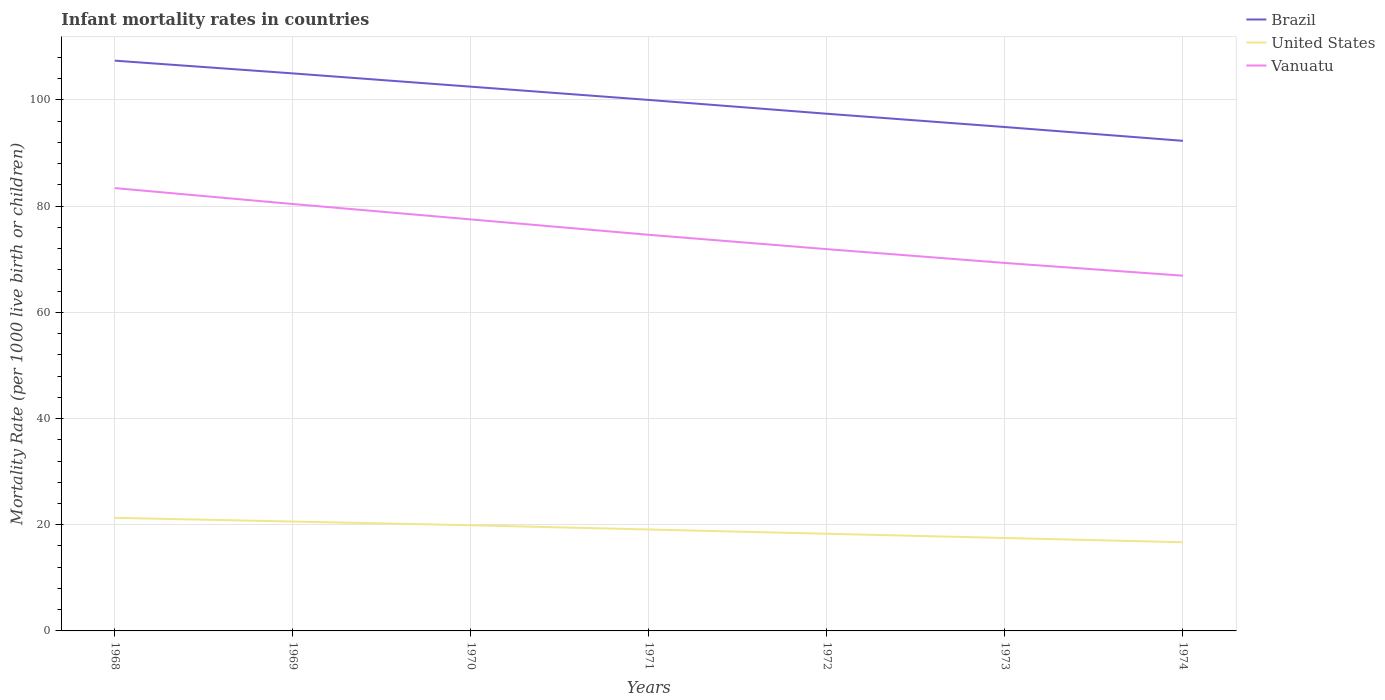Across all years, what is the maximum infant mortality rate in Brazil?
Your answer should be very brief. 92.3. In which year was the infant mortality rate in United States maximum?
Offer a very short reply. 1974. What is the difference between the highest and the second highest infant mortality rate in United States?
Offer a very short reply. 4.6. What is the difference between the highest and the lowest infant mortality rate in United States?
Your answer should be compact. 4. How many lines are there?
Give a very brief answer. 3. Where does the legend appear in the graph?
Make the answer very short. Top right. How many legend labels are there?
Ensure brevity in your answer.  3. What is the title of the graph?
Offer a terse response. Infant mortality rates in countries. What is the label or title of the X-axis?
Your answer should be very brief. Years. What is the label or title of the Y-axis?
Make the answer very short. Mortality Rate (per 1000 live birth or children). What is the Mortality Rate (per 1000 live birth or children) in Brazil in 1968?
Give a very brief answer. 107.4. What is the Mortality Rate (per 1000 live birth or children) in United States in 1968?
Give a very brief answer. 21.3. What is the Mortality Rate (per 1000 live birth or children) in Vanuatu in 1968?
Your response must be concise. 83.4. What is the Mortality Rate (per 1000 live birth or children) in Brazil in 1969?
Your response must be concise. 105. What is the Mortality Rate (per 1000 live birth or children) of United States in 1969?
Provide a short and direct response. 20.6. What is the Mortality Rate (per 1000 live birth or children) of Vanuatu in 1969?
Your answer should be compact. 80.4. What is the Mortality Rate (per 1000 live birth or children) of Brazil in 1970?
Your answer should be very brief. 102.5. What is the Mortality Rate (per 1000 live birth or children) of Vanuatu in 1970?
Your response must be concise. 77.5. What is the Mortality Rate (per 1000 live birth or children) in Vanuatu in 1971?
Your response must be concise. 74.6. What is the Mortality Rate (per 1000 live birth or children) in Brazil in 1972?
Your answer should be compact. 97.4. What is the Mortality Rate (per 1000 live birth or children) in United States in 1972?
Your answer should be compact. 18.3. What is the Mortality Rate (per 1000 live birth or children) of Vanuatu in 1972?
Offer a terse response. 71.9. What is the Mortality Rate (per 1000 live birth or children) of Brazil in 1973?
Keep it short and to the point. 94.9. What is the Mortality Rate (per 1000 live birth or children) in Vanuatu in 1973?
Make the answer very short. 69.3. What is the Mortality Rate (per 1000 live birth or children) of Brazil in 1974?
Your response must be concise. 92.3. What is the Mortality Rate (per 1000 live birth or children) in Vanuatu in 1974?
Provide a succinct answer. 66.9. Across all years, what is the maximum Mortality Rate (per 1000 live birth or children) in Brazil?
Provide a short and direct response. 107.4. Across all years, what is the maximum Mortality Rate (per 1000 live birth or children) of United States?
Make the answer very short. 21.3. Across all years, what is the maximum Mortality Rate (per 1000 live birth or children) in Vanuatu?
Offer a very short reply. 83.4. Across all years, what is the minimum Mortality Rate (per 1000 live birth or children) of Brazil?
Ensure brevity in your answer.  92.3. Across all years, what is the minimum Mortality Rate (per 1000 live birth or children) in Vanuatu?
Offer a terse response. 66.9. What is the total Mortality Rate (per 1000 live birth or children) of Brazil in the graph?
Keep it short and to the point. 699.5. What is the total Mortality Rate (per 1000 live birth or children) of United States in the graph?
Ensure brevity in your answer.  133.4. What is the total Mortality Rate (per 1000 live birth or children) of Vanuatu in the graph?
Offer a very short reply. 524. What is the difference between the Mortality Rate (per 1000 live birth or children) in Vanuatu in 1968 and that in 1969?
Provide a succinct answer. 3. What is the difference between the Mortality Rate (per 1000 live birth or children) in United States in 1968 and that in 1970?
Ensure brevity in your answer.  1.4. What is the difference between the Mortality Rate (per 1000 live birth or children) of United States in 1968 and that in 1971?
Your response must be concise. 2.2. What is the difference between the Mortality Rate (per 1000 live birth or children) in Vanuatu in 1968 and that in 1971?
Offer a very short reply. 8.8. What is the difference between the Mortality Rate (per 1000 live birth or children) in Brazil in 1968 and that in 1972?
Make the answer very short. 10. What is the difference between the Mortality Rate (per 1000 live birth or children) of Vanuatu in 1968 and that in 1972?
Keep it short and to the point. 11.5. What is the difference between the Mortality Rate (per 1000 live birth or children) in Brazil in 1968 and that in 1973?
Ensure brevity in your answer.  12.5. What is the difference between the Mortality Rate (per 1000 live birth or children) in United States in 1968 and that in 1973?
Give a very brief answer. 3.8. What is the difference between the Mortality Rate (per 1000 live birth or children) of Brazil in 1968 and that in 1974?
Keep it short and to the point. 15.1. What is the difference between the Mortality Rate (per 1000 live birth or children) in United States in 1968 and that in 1974?
Provide a succinct answer. 4.6. What is the difference between the Mortality Rate (per 1000 live birth or children) of Vanuatu in 1968 and that in 1974?
Give a very brief answer. 16.5. What is the difference between the Mortality Rate (per 1000 live birth or children) of Brazil in 1969 and that in 1970?
Provide a short and direct response. 2.5. What is the difference between the Mortality Rate (per 1000 live birth or children) of United States in 1969 and that in 1970?
Your answer should be compact. 0.7. What is the difference between the Mortality Rate (per 1000 live birth or children) in Brazil in 1969 and that in 1971?
Provide a succinct answer. 5. What is the difference between the Mortality Rate (per 1000 live birth or children) in Brazil in 1969 and that in 1972?
Provide a short and direct response. 7.6. What is the difference between the Mortality Rate (per 1000 live birth or children) of Vanuatu in 1969 and that in 1972?
Offer a very short reply. 8.5. What is the difference between the Mortality Rate (per 1000 live birth or children) in United States in 1969 and that in 1973?
Keep it short and to the point. 3.1. What is the difference between the Mortality Rate (per 1000 live birth or children) in Brazil in 1970 and that in 1971?
Offer a very short reply. 2.5. What is the difference between the Mortality Rate (per 1000 live birth or children) in United States in 1970 and that in 1971?
Offer a terse response. 0.8. What is the difference between the Mortality Rate (per 1000 live birth or children) in United States in 1970 and that in 1973?
Your answer should be compact. 2.4. What is the difference between the Mortality Rate (per 1000 live birth or children) of United States in 1970 and that in 1974?
Provide a succinct answer. 3.2. What is the difference between the Mortality Rate (per 1000 live birth or children) of Brazil in 1971 and that in 1972?
Make the answer very short. 2.6. What is the difference between the Mortality Rate (per 1000 live birth or children) of Vanuatu in 1971 and that in 1972?
Ensure brevity in your answer.  2.7. What is the difference between the Mortality Rate (per 1000 live birth or children) in Brazil in 1971 and that in 1974?
Make the answer very short. 7.7. What is the difference between the Mortality Rate (per 1000 live birth or children) in Vanuatu in 1971 and that in 1974?
Keep it short and to the point. 7.7. What is the difference between the Mortality Rate (per 1000 live birth or children) in Brazil in 1972 and that in 1973?
Provide a succinct answer. 2.5. What is the difference between the Mortality Rate (per 1000 live birth or children) of United States in 1972 and that in 1974?
Provide a short and direct response. 1.6. What is the difference between the Mortality Rate (per 1000 live birth or children) of Vanuatu in 1972 and that in 1974?
Offer a terse response. 5. What is the difference between the Mortality Rate (per 1000 live birth or children) in Brazil in 1968 and the Mortality Rate (per 1000 live birth or children) in United States in 1969?
Provide a short and direct response. 86.8. What is the difference between the Mortality Rate (per 1000 live birth or children) of United States in 1968 and the Mortality Rate (per 1000 live birth or children) of Vanuatu in 1969?
Provide a succinct answer. -59.1. What is the difference between the Mortality Rate (per 1000 live birth or children) of Brazil in 1968 and the Mortality Rate (per 1000 live birth or children) of United States in 1970?
Keep it short and to the point. 87.5. What is the difference between the Mortality Rate (per 1000 live birth or children) in Brazil in 1968 and the Mortality Rate (per 1000 live birth or children) in Vanuatu in 1970?
Offer a very short reply. 29.9. What is the difference between the Mortality Rate (per 1000 live birth or children) in United States in 1968 and the Mortality Rate (per 1000 live birth or children) in Vanuatu in 1970?
Give a very brief answer. -56.2. What is the difference between the Mortality Rate (per 1000 live birth or children) in Brazil in 1968 and the Mortality Rate (per 1000 live birth or children) in United States in 1971?
Provide a succinct answer. 88.3. What is the difference between the Mortality Rate (per 1000 live birth or children) in Brazil in 1968 and the Mortality Rate (per 1000 live birth or children) in Vanuatu in 1971?
Your answer should be very brief. 32.8. What is the difference between the Mortality Rate (per 1000 live birth or children) of United States in 1968 and the Mortality Rate (per 1000 live birth or children) of Vanuatu in 1971?
Your answer should be compact. -53.3. What is the difference between the Mortality Rate (per 1000 live birth or children) in Brazil in 1968 and the Mortality Rate (per 1000 live birth or children) in United States in 1972?
Provide a short and direct response. 89.1. What is the difference between the Mortality Rate (per 1000 live birth or children) of Brazil in 1968 and the Mortality Rate (per 1000 live birth or children) of Vanuatu in 1972?
Give a very brief answer. 35.5. What is the difference between the Mortality Rate (per 1000 live birth or children) of United States in 1968 and the Mortality Rate (per 1000 live birth or children) of Vanuatu in 1972?
Keep it short and to the point. -50.6. What is the difference between the Mortality Rate (per 1000 live birth or children) of Brazil in 1968 and the Mortality Rate (per 1000 live birth or children) of United States in 1973?
Your answer should be compact. 89.9. What is the difference between the Mortality Rate (per 1000 live birth or children) in Brazil in 1968 and the Mortality Rate (per 1000 live birth or children) in Vanuatu in 1973?
Keep it short and to the point. 38.1. What is the difference between the Mortality Rate (per 1000 live birth or children) in United States in 1968 and the Mortality Rate (per 1000 live birth or children) in Vanuatu in 1973?
Offer a terse response. -48. What is the difference between the Mortality Rate (per 1000 live birth or children) of Brazil in 1968 and the Mortality Rate (per 1000 live birth or children) of United States in 1974?
Provide a short and direct response. 90.7. What is the difference between the Mortality Rate (per 1000 live birth or children) of Brazil in 1968 and the Mortality Rate (per 1000 live birth or children) of Vanuatu in 1974?
Your answer should be very brief. 40.5. What is the difference between the Mortality Rate (per 1000 live birth or children) in United States in 1968 and the Mortality Rate (per 1000 live birth or children) in Vanuatu in 1974?
Offer a very short reply. -45.6. What is the difference between the Mortality Rate (per 1000 live birth or children) of Brazil in 1969 and the Mortality Rate (per 1000 live birth or children) of United States in 1970?
Keep it short and to the point. 85.1. What is the difference between the Mortality Rate (per 1000 live birth or children) of Brazil in 1969 and the Mortality Rate (per 1000 live birth or children) of Vanuatu in 1970?
Ensure brevity in your answer.  27.5. What is the difference between the Mortality Rate (per 1000 live birth or children) in United States in 1969 and the Mortality Rate (per 1000 live birth or children) in Vanuatu in 1970?
Provide a succinct answer. -56.9. What is the difference between the Mortality Rate (per 1000 live birth or children) of Brazil in 1969 and the Mortality Rate (per 1000 live birth or children) of United States in 1971?
Offer a terse response. 85.9. What is the difference between the Mortality Rate (per 1000 live birth or children) in Brazil in 1969 and the Mortality Rate (per 1000 live birth or children) in Vanuatu in 1971?
Your answer should be very brief. 30.4. What is the difference between the Mortality Rate (per 1000 live birth or children) of United States in 1969 and the Mortality Rate (per 1000 live birth or children) of Vanuatu in 1971?
Your answer should be very brief. -54. What is the difference between the Mortality Rate (per 1000 live birth or children) of Brazil in 1969 and the Mortality Rate (per 1000 live birth or children) of United States in 1972?
Ensure brevity in your answer.  86.7. What is the difference between the Mortality Rate (per 1000 live birth or children) of Brazil in 1969 and the Mortality Rate (per 1000 live birth or children) of Vanuatu in 1972?
Give a very brief answer. 33.1. What is the difference between the Mortality Rate (per 1000 live birth or children) in United States in 1969 and the Mortality Rate (per 1000 live birth or children) in Vanuatu in 1972?
Ensure brevity in your answer.  -51.3. What is the difference between the Mortality Rate (per 1000 live birth or children) in Brazil in 1969 and the Mortality Rate (per 1000 live birth or children) in United States in 1973?
Offer a very short reply. 87.5. What is the difference between the Mortality Rate (per 1000 live birth or children) of Brazil in 1969 and the Mortality Rate (per 1000 live birth or children) of Vanuatu in 1973?
Give a very brief answer. 35.7. What is the difference between the Mortality Rate (per 1000 live birth or children) of United States in 1969 and the Mortality Rate (per 1000 live birth or children) of Vanuatu in 1973?
Provide a succinct answer. -48.7. What is the difference between the Mortality Rate (per 1000 live birth or children) in Brazil in 1969 and the Mortality Rate (per 1000 live birth or children) in United States in 1974?
Ensure brevity in your answer.  88.3. What is the difference between the Mortality Rate (per 1000 live birth or children) of Brazil in 1969 and the Mortality Rate (per 1000 live birth or children) of Vanuatu in 1974?
Make the answer very short. 38.1. What is the difference between the Mortality Rate (per 1000 live birth or children) of United States in 1969 and the Mortality Rate (per 1000 live birth or children) of Vanuatu in 1974?
Offer a very short reply. -46.3. What is the difference between the Mortality Rate (per 1000 live birth or children) of Brazil in 1970 and the Mortality Rate (per 1000 live birth or children) of United States in 1971?
Your answer should be very brief. 83.4. What is the difference between the Mortality Rate (per 1000 live birth or children) of Brazil in 1970 and the Mortality Rate (per 1000 live birth or children) of Vanuatu in 1971?
Your response must be concise. 27.9. What is the difference between the Mortality Rate (per 1000 live birth or children) of United States in 1970 and the Mortality Rate (per 1000 live birth or children) of Vanuatu in 1971?
Your answer should be very brief. -54.7. What is the difference between the Mortality Rate (per 1000 live birth or children) of Brazil in 1970 and the Mortality Rate (per 1000 live birth or children) of United States in 1972?
Make the answer very short. 84.2. What is the difference between the Mortality Rate (per 1000 live birth or children) in Brazil in 1970 and the Mortality Rate (per 1000 live birth or children) in Vanuatu in 1972?
Ensure brevity in your answer.  30.6. What is the difference between the Mortality Rate (per 1000 live birth or children) of United States in 1970 and the Mortality Rate (per 1000 live birth or children) of Vanuatu in 1972?
Your answer should be very brief. -52. What is the difference between the Mortality Rate (per 1000 live birth or children) in Brazil in 1970 and the Mortality Rate (per 1000 live birth or children) in United States in 1973?
Offer a very short reply. 85. What is the difference between the Mortality Rate (per 1000 live birth or children) of Brazil in 1970 and the Mortality Rate (per 1000 live birth or children) of Vanuatu in 1973?
Provide a short and direct response. 33.2. What is the difference between the Mortality Rate (per 1000 live birth or children) of United States in 1970 and the Mortality Rate (per 1000 live birth or children) of Vanuatu in 1973?
Offer a terse response. -49.4. What is the difference between the Mortality Rate (per 1000 live birth or children) of Brazil in 1970 and the Mortality Rate (per 1000 live birth or children) of United States in 1974?
Provide a short and direct response. 85.8. What is the difference between the Mortality Rate (per 1000 live birth or children) in Brazil in 1970 and the Mortality Rate (per 1000 live birth or children) in Vanuatu in 1974?
Offer a very short reply. 35.6. What is the difference between the Mortality Rate (per 1000 live birth or children) in United States in 1970 and the Mortality Rate (per 1000 live birth or children) in Vanuatu in 1974?
Give a very brief answer. -47. What is the difference between the Mortality Rate (per 1000 live birth or children) of Brazil in 1971 and the Mortality Rate (per 1000 live birth or children) of United States in 1972?
Provide a short and direct response. 81.7. What is the difference between the Mortality Rate (per 1000 live birth or children) in Brazil in 1971 and the Mortality Rate (per 1000 live birth or children) in Vanuatu in 1972?
Keep it short and to the point. 28.1. What is the difference between the Mortality Rate (per 1000 live birth or children) of United States in 1971 and the Mortality Rate (per 1000 live birth or children) of Vanuatu in 1972?
Offer a very short reply. -52.8. What is the difference between the Mortality Rate (per 1000 live birth or children) in Brazil in 1971 and the Mortality Rate (per 1000 live birth or children) in United States in 1973?
Your answer should be very brief. 82.5. What is the difference between the Mortality Rate (per 1000 live birth or children) in Brazil in 1971 and the Mortality Rate (per 1000 live birth or children) in Vanuatu in 1973?
Ensure brevity in your answer.  30.7. What is the difference between the Mortality Rate (per 1000 live birth or children) of United States in 1971 and the Mortality Rate (per 1000 live birth or children) of Vanuatu in 1973?
Your answer should be very brief. -50.2. What is the difference between the Mortality Rate (per 1000 live birth or children) in Brazil in 1971 and the Mortality Rate (per 1000 live birth or children) in United States in 1974?
Provide a short and direct response. 83.3. What is the difference between the Mortality Rate (per 1000 live birth or children) in Brazil in 1971 and the Mortality Rate (per 1000 live birth or children) in Vanuatu in 1974?
Make the answer very short. 33.1. What is the difference between the Mortality Rate (per 1000 live birth or children) of United States in 1971 and the Mortality Rate (per 1000 live birth or children) of Vanuatu in 1974?
Provide a short and direct response. -47.8. What is the difference between the Mortality Rate (per 1000 live birth or children) in Brazil in 1972 and the Mortality Rate (per 1000 live birth or children) in United States in 1973?
Provide a succinct answer. 79.9. What is the difference between the Mortality Rate (per 1000 live birth or children) in Brazil in 1972 and the Mortality Rate (per 1000 live birth or children) in Vanuatu in 1973?
Ensure brevity in your answer.  28.1. What is the difference between the Mortality Rate (per 1000 live birth or children) in United States in 1972 and the Mortality Rate (per 1000 live birth or children) in Vanuatu in 1973?
Provide a succinct answer. -51. What is the difference between the Mortality Rate (per 1000 live birth or children) of Brazil in 1972 and the Mortality Rate (per 1000 live birth or children) of United States in 1974?
Your response must be concise. 80.7. What is the difference between the Mortality Rate (per 1000 live birth or children) of Brazil in 1972 and the Mortality Rate (per 1000 live birth or children) of Vanuatu in 1974?
Offer a terse response. 30.5. What is the difference between the Mortality Rate (per 1000 live birth or children) in United States in 1972 and the Mortality Rate (per 1000 live birth or children) in Vanuatu in 1974?
Ensure brevity in your answer.  -48.6. What is the difference between the Mortality Rate (per 1000 live birth or children) of Brazil in 1973 and the Mortality Rate (per 1000 live birth or children) of United States in 1974?
Provide a succinct answer. 78.2. What is the difference between the Mortality Rate (per 1000 live birth or children) in United States in 1973 and the Mortality Rate (per 1000 live birth or children) in Vanuatu in 1974?
Provide a short and direct response. -49.4. What is the average Mortality Rate (per 1000 live birth or children) in Brazil per year?
Your answer should be compact. 99.93. What is the average Mortality Rate (per 1000 live birth or children) in United States per year?
Offer a terse response. 19.06. What is the average Mortality Rate (per 1000 live birth or children) of Vanuatu per year?
Offer a terse response. 74.86. In the year 1968, what is the difference between the Mortality Rate (per 1000 live birth or children) of Brazil and Mortality Rate (per 1000 live birth or children) of United States?
Keep it short and to the point. 86.1. In the year 1968, what is the difference between the Mortality Rate (per 1000 live birth or children) of United States and Mortality Rate (per 1000 live birth or children) of Vanuatu?
Give a very brief answer. -62.1. In the year 1969, what is the difference between the Mortality Rate (per 1000 live birth or children) of Brazil and Mortality Rate (per 1000 live birth or children) of United States?
Your answer should be very brief. 84.4. In the year 1969, what is the difference between the Mortality Rate (per 1000 live birth or children) of Brazil and Mortality Rate (per 1000 live birth or children) of Vanuatu?
Make the answer very short. 24.6. In the year 1969, what is the difference between the Mortality Rate (per 1000 live birth or children) in United States and Mortality Rate (per 1000 live birth or children) in Vanuatu?
Make the answer very short. -59.8. In the year 1970, what is the difference between the Mortality Rate (per 1000 live birth or children) in Brazil and Mortality Rate (per 1000 live birth or children) in United States?
Offer a very short reply. 82.6. In the year 1970, what is the difference between the Mortality Rate (per 1000 live birth or children) of United States and Mortality Rate (per 1000 live birth or children) of Vanuatu?
Give a very brief answer. -57.6. In the year 1971, what is the difference between the Mortality Rate (per 1000 live birth or children) of Brazil and Mortality Rate (per 1000 live birth or children) of United States?
Offer a terse response. 80.9. In the year 1971, what is the difference between the Mortality Rate (per 1000 live birth or children) in Brazil and Mortality Rate (per 1000 live birth or children) in Vanuatu?
Provide a succinct answer. 25.4. In the year 1971, what is the difference between the Mortality Rate (per 1000 live birth or children) of United States and Mortality Rate (per 1000 live birth or children) of Vanuatu?
Make the answer very short. -55.5. In the year 1972, what is the difference between the Mortality Rate (per 1000 live birth or children) in Brazil and Mortality Rate (per 1000 live birth or children) in United States?
Ensure brevity in your answer.  79.1. In the year 1972, what is the difference between the Mortality Rate (per 1000 live birth or children) in United States and Mortality Rate (per 1000 live birth or children) in Vanuatu?
Your answer should be very brief. -53.6. In the year 1973, what is the difference between the Mortality Rate (per 1000 live birth or children) in Brazil and Mortality Rate (per 1000 live birth or children) in United States?
Your answer should be very brief. 77.4. In the year 1973, what is the difference between the Mortality Rate (per 1000 live birth or children) of Brazil and Mortality Rate (per 1000 live birth or children) of Vanuatu?
Provide a short and direct response. 25.6. In the year 1973, what is the difference between the Mortality Rate (per 1000 live birth or children) in United States and Mortality Rate (per 1000 live birth or children) in Vanuatu?
Offer a very short reply. -51.8. In the year 1974, what is the difference between the Mortality Rate (per 1000 live birth or children) of Brazil and Mortality Rate (per 1000 live birth or children) of United States?
Provide a succinct answer. 75.6. In the year 1974, what is the difference between the Mortality Rate (per 1000 live birth or children) of Brazil and Mortality Rate (per 1000 live birth or children) of Vanuatu?
Your answer should be very brief. 25.4. In the year 1974, what is the difference between the Mortality Rate (per 1000 live birth or children) of United States and Mortality Rate (per 1000 live birth or children) of Vanuatu?
Offer a very short reply. -50.2. What is the ratio of the Mortality Rate (per 1000 live birth or children) of Brazil in 1968 to that in 1969?
Provide a short and direct response. 1.02. What is the ratio of the Mortality Rate (per 1000 live birth or children) of United States in 1968 to that in 1969?
Your answer should be compact. 1.03. What is the ratio of the Mortality Rate (per 1000 live birth or children) of Vanuatu in 1968 to that in 1969?
Your response must be concise. 1.04. What is the ratio of the Mortality Rate (per 1000 live birth or children) in Brazil in 1968 to that in 1970?
Keep it short and to the point. 1.05. What is the ratio of the Mortality Rate (per 1000 live birth or children) of United States in 1968 to that in 1970?
Offer a terse response. 1.07. What is the ratio of the Mortality Rate (per 1000 live birth or children) in Vanuatu in 1968 to that in 1970?
Keep it short and to the point. 1.08. What is the ratio of the Mortality Rate (per 1000 live birth or children) of Brazil in 1968 to that in 1971?
Provide a short and direct response. 1.07. What is the ratio of the Mortality Rate (per 1000 live birth or children) of United States in 1968 to that in 1971?
Offer a terse response. 1.12. What is the ratio of the Mortality Rate (per 1000 live birth or children) of Vanuatu in 1968 to that in 1971?
Your answer should be very brief. 1.12. What is the ratio of the Mortality Rate (per 1000 live birth or children) of Brazil in 1968 to that in 1972?
Give a very brief answer. 1.1. What is the ratio of the Mortality Rate (per 1000 live birth or children) in United States in 1968 to that in 1972?
Give a very brief answer. 1.16. What is the ratio of the Mortality Rate (per 1000 live birth or children) of Vanuatu in 1968 to that in 1972?
Give a very brief answer. 1.16. What is the ratio of the Mortality Rate (per 1000 live birth or children) of Brazil in 1968 to that in 1973?
Your answer should be compact. 1.13. What is the ratio of the Mortality Rate (per 1000 live birth or children) of United States in 1968 to that in 1973?
Give a very brief answer. 1.22. What is the ratio of the Mortality Rate (per 1000 live birth or children) of Vanuatu in 1968 to that in 1973?
Your response must be concise. 1.2. What is the ratio of the Mortality Rate (per 1000 live birth or children) in Brazil in 1968 to that in 1974?
Keep it short and to the point. 1.16. What is the ratio of the Mortality Rate (per 1000 live birth or children) in United States in 1968 to that in 1974?
Offer a very short reply. 1.28. What is the ratio of the Mortality Rate (per 1000 live birth or children) in Vanuatu in 1968 to that in 1974?
Give a very brief answer. 1.25. What is the ratio of the Mortality Rate (per 1000 live birth or children) of Brazil in 1969 to that in 1970?
Your answer should be compact. 1.02. What is the ratio of the Mortality Rate (per 1000 live birth or children) of United States in 1969 to that in 1970?
Provide a succinct answer. 1.04. What is the ratio of the Mortality Rate (per 1000 live birth or children) of Vanuatu in 1969 to that in 1970?
Make the answer very short. 1.04. What is the ratio of the Mortality Rate (per 1000 live birth or children) of Brazil in 1969 to that in 1971?
Your response must be concise. 1.05. What is the ratio of the Mortality Rate (per 1000 live birth or children) in United States in 1969 to that in 1971?
Provide a short and direct response. 1.08. What is the ratio of the Mortality Rate (per 1000 live birth or children) in Vanuatu in 1969 to that in 1971?
Provide a succinct answer. 1.08. What is the ratio of the Mortality Rate (per 1000 live birth or children) of Brazil in 1969 to that in 1972?
Offer a very short reply. 1.08. What is the ratio of the Mortality Rate (per 1000 live birth or children) in United States in 1969 to that in 1972?
Ensure brevity in your answer.  1.13. What is the ratio of the Mortality Rate (per 1000 live birth or children) of Vanuatu in 1969 to that in 1972?
Provide a succinct answer. 1.12. What is the ratio of the Mortality Rate (per 1000 live birth or children) of Brazil in 1969 to that in 1973?
Offer a terse response. 1.11. What is the ratio of the Mortality Rate (per 1000 live birth or children) in United States in 1969 to that in 1973?
Give a very brief answer. 1.18. What is the ratio of the Mortality Rate (per 1000 live birth or children) in Vanuatu in 1969 to that in 1973?
Make the answer very short. 1.16. What is the ratio of the Mortality Rate (per 1000 live birth or children) of Brazil in 1969 to that in 1974?
Make the answer very short. 1.14. What is the ratio of the Mortality Rate (per 1000 live birth or children) of United States in 1969 to that in 1974?
Provide a succinct answer. 1.23. What is the ratio of the Mortality Rate (per 1000 live birth or children) in Vanuatu in 1969 to that in 1974?
Provide a short and direct response. 1.2. What is the ratio of the Mortality Rate (per 1000 live birth or children) in Brazil in 1970 to that in 1971?
Your answer should be compact. 1.02. What is the ratio of the Mortality Rate (per 1000 live birth or children) in United States in 1970 to that in 1971?
Keep it short and to the point. 1.04. What is the ratio of the Mortality Rate (per 1000 live birth or children) in Vanuatu in 1970 to that in 1971?
Provide a short and direct response. 1.04. What is the ratio of the Mortality Rate (per 1000 live birth or children) of Brazil in 1970 to that in 1972?
Keep it short and to the point. 1.05. What is the ratio of the Mortality Rate (per 1000 live birth or children) of United States in 1970 to that in 1972?
Your answer should be very brief. 1.09. What is the ratio of the Mortality Rate (per 1000 live birth or children) of Vanuatu in 1970 to that in 1972?
Offer a very short reply. 1.08. What is the ratio of the Mortality Rate (per 1000 live birth or children) of Brazil in 1970 to that in 1973?
Keep it short and to the point. 1.08. What is the ratio of the Mortality Rate (per 1000 live birth or children) in United States in 1970 to that in 1973?
Offer a very short reply. 1.14. What is the ratio of the Mortality Rate (per 1000 live birth or children) of Vanuatu in 1970 to that in 1973?
Make the answer very short. 1.12. What is the ratio of the Mortality Rate (per 1000 live birth or children) of Brazil in 1970 to that in 1974?
Give a very brief answer. 1.11. What is the ratio of the Mortality Rate (per 1000 live birth or children) of United States in 1970 to that in 1974?
Your response must be concise. 1.19. What is the ratio of the Mortality Rate (per 1000 live birth or children) of Vanuatu in 1970 to that in 1974?
Your answer should be compact. 1.16. What is the ratio of the Mortality Rate (per 1000 live birth or children) of Brazil in 1971 to that in 1972?
Ensure brevity in your answer.  1.03. What is the ratio of the Mortality Rate (per 1000 live birth or children) of United States in 1971 to that in 1972?
Make the answer very short. 1.04. What is the ratio of the Mortality Rate (per 1000 live birth or children) of Vanuatu in 1971 to that in 1972?
Offer a very short reply. 1.04. What is the ratio of the Mortality Rate (per 1000 live birth or children) in Brazil in 1971 to that in 1973?
Your answer should be very brief. 1.05. What is the ratio of the Mortality Rate (per 1000 live birth or children) in United States in 1971 to that in 1973?
Your answer should be very brief. 1.09. What is the ratio of the Mortality Rate (per 1000 live birth or children) in Vanuatu in 1971 to that in 1973?
Give a very brief answer. 1.08. What is the ratio of the Mortality Rate (per 1000 live birth or children) in Brazil in 1971 to that in 1974?
Your answer should be compact. 1.08. What is the ratio of the Mortality Rate (per 1000 live birth or children) of United States in 1971 to that in 1974?
Provide a short and direct response. 1.14. What is the ratio of the Mortality Rate (per 1000 live birth or children) in Vanuatu in 1971 to that in 1974?
Make the answer very short. 1.12. What is the ratio of the Mortality Rate (per 1000 live birth or children) of Brazil in 1972 to that in 1973?
Give a very brief answer. 1.03. What is the ratio of the Mortality Rate (per 1000 live birth or children) in United States in 1972 to that in 1973?
Ensure brevity in your answer.  1.05. What is the ratio of the Mortality Rate (per 1000 live birth or children) of Vanuatu in 1972 to that in 1973?
Make the answer very short. 1.04. What is the ratio of the Mortality Rate (per 1000 live birth or children) in Brazil in 1972 to that in 1974?
Give a very brief answer. 1.06. What is the ratio of the Mortality Rate (per 1000 live birth or children) of United States in 1972 to that in 1974?
Offer a very short reply. 1.1. What is the ratio of the Mortality Rate (per 1000 live birth or children) of Vanuatu in 1972 to that in 1974?
Ensure brevity in your answer.  1.07. What is the ratio of the Mortality Rate (per 1000 live birth or children) of Brazil in 1973 to that in 1974?
Provide a succinct answer. 1.03. What is the ratio of the Mortality Rate (per 1000 live birth or children) of United States in 1973 to that in 1974?
Your answer should be compact. 1.05. What is the ratio of the Mortality Rate (per 1000 live birth or children) in Vanuatu in 1973 to that in 1974?
Provide a succinct answer. 1.04. What is the difference between the highest and the lowest Mortality Rate (per 1000 live birth or children) of Brazil?
Give a very brief answer. 15.1. 